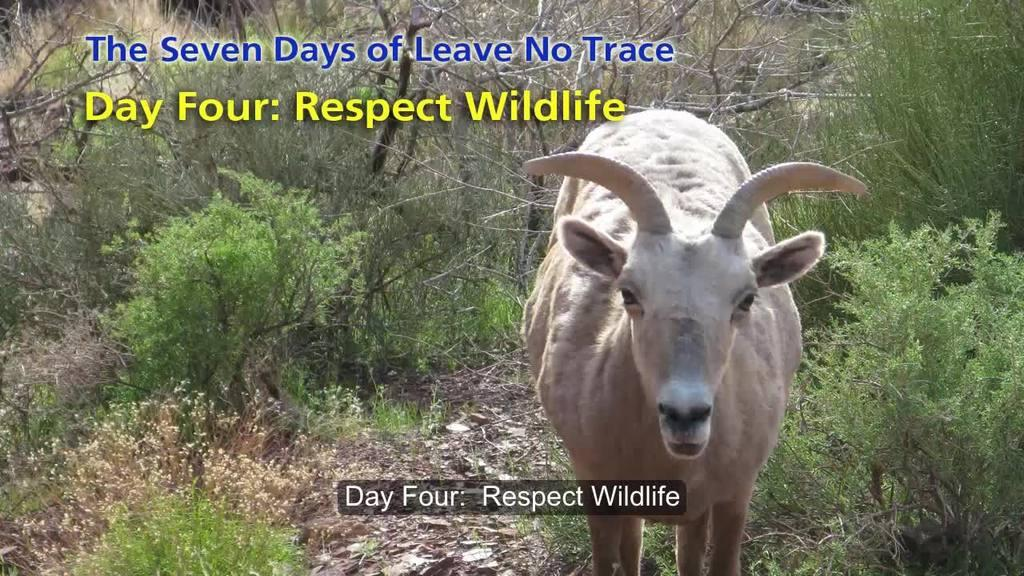What type of animal is on the ground in the image? There is a goat on the ground in the image. What else can be seen on the ground in the image? There are plants and trees on the ground in the image. Is there any text present in the image? Yes, there is some text present in the image. What type of disease can be seen affecting the goat in the image? There is no indication of any disease affecting the goat in the image. What type of brick structure is visible in the image? There is no brick structure present in the image. 